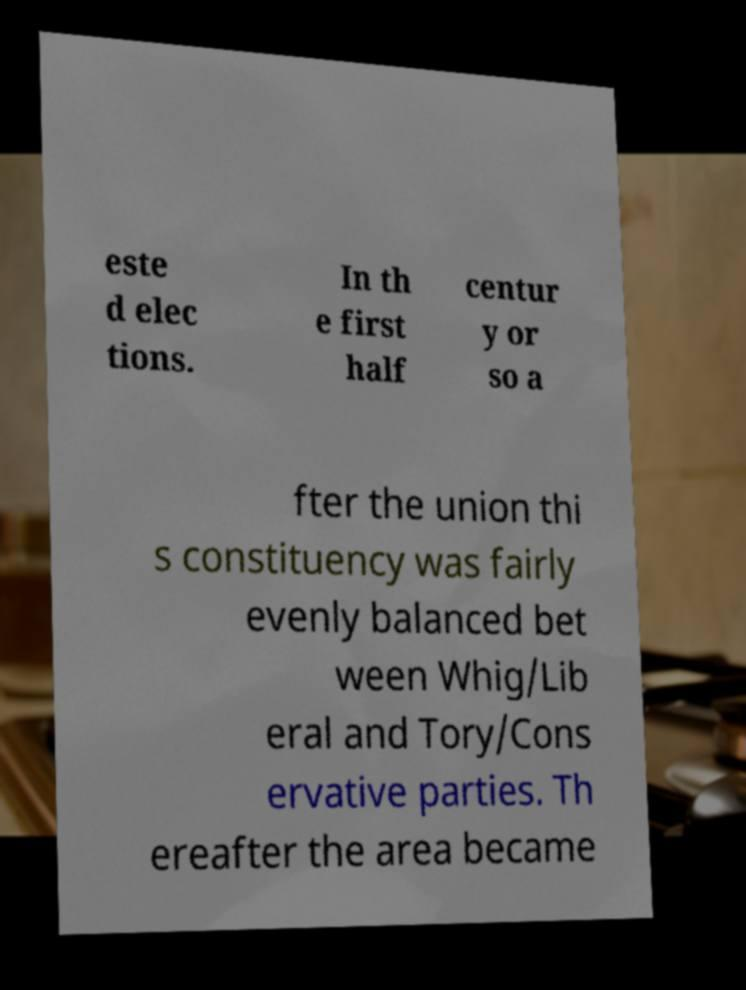For documentation purposes, I need the text within this image transcribed. Could you provide that? este d elec tions. In th e first half centur y or so a fter the union thi s constituency was fairly evenly balanced bet ween Whig/Lib eral and Tory/Cons ervative parties. Th ereafter the area became 